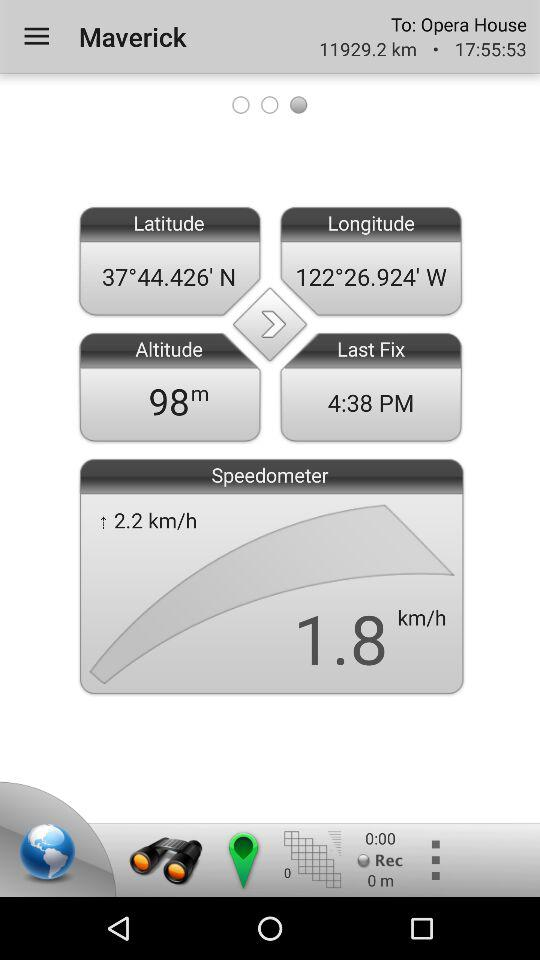How long has the user been driving for?
Answer the question using a single word or phrase. 0:00 